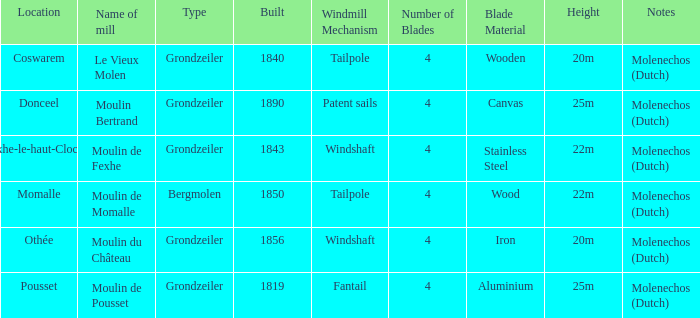What is year Built of the Moulin de Momalle Mill? 1850.0. 